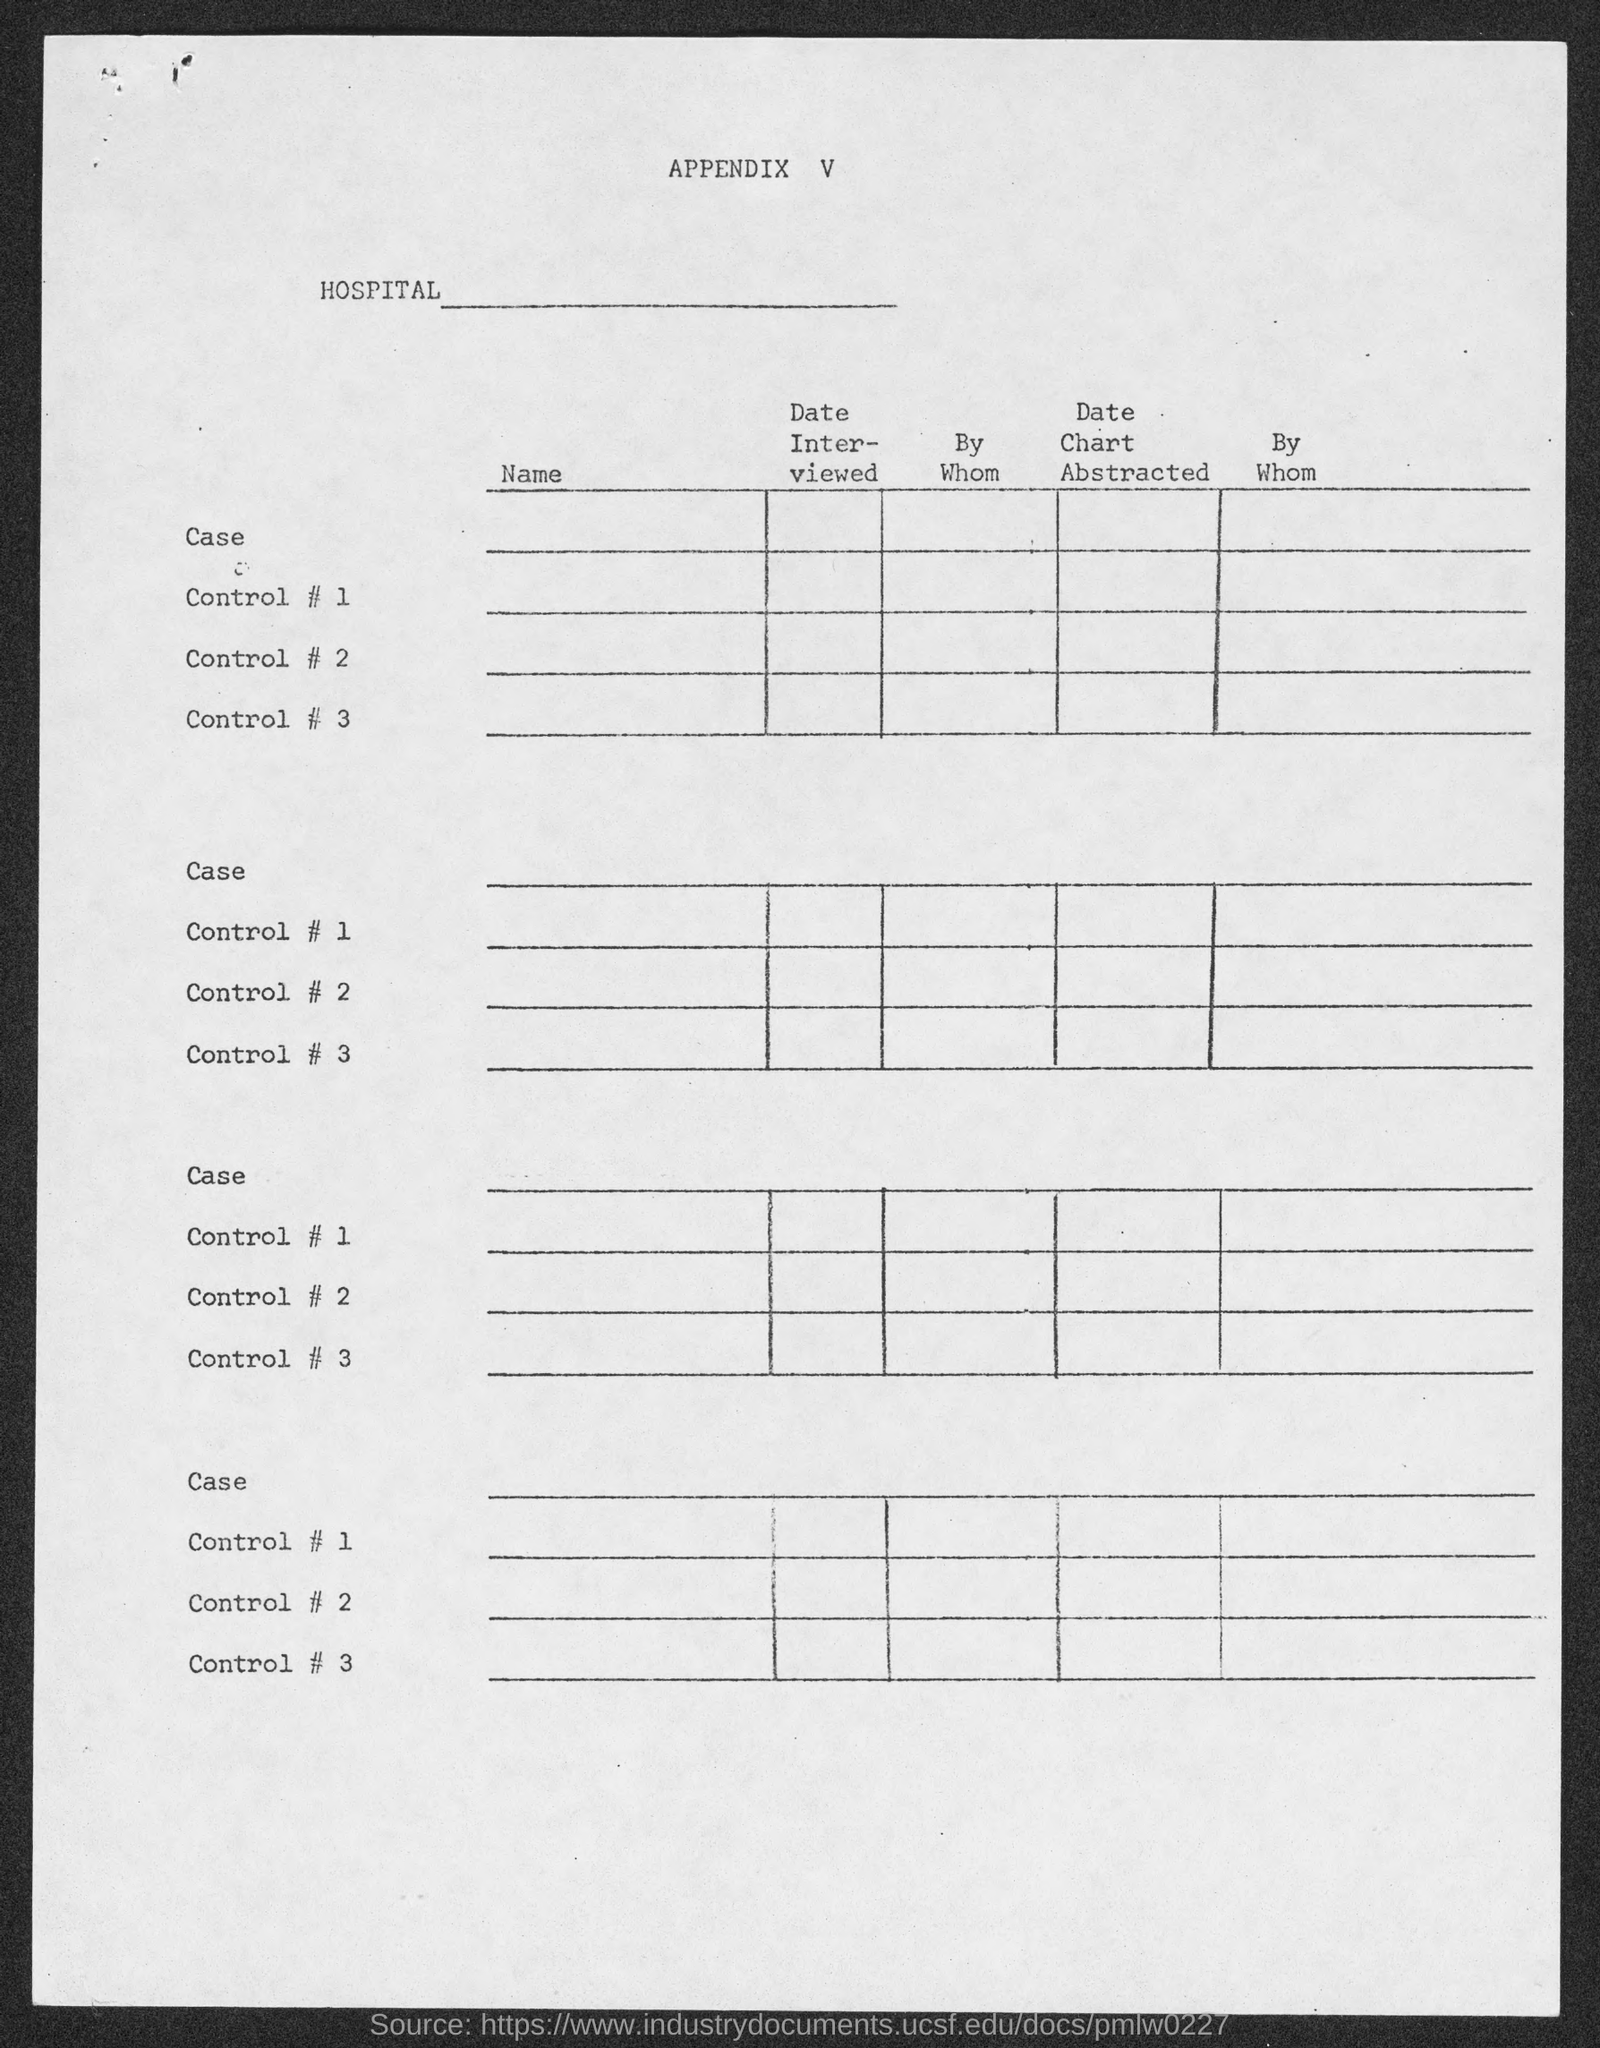What is the appendix no.?
Your response must be concise. V. 